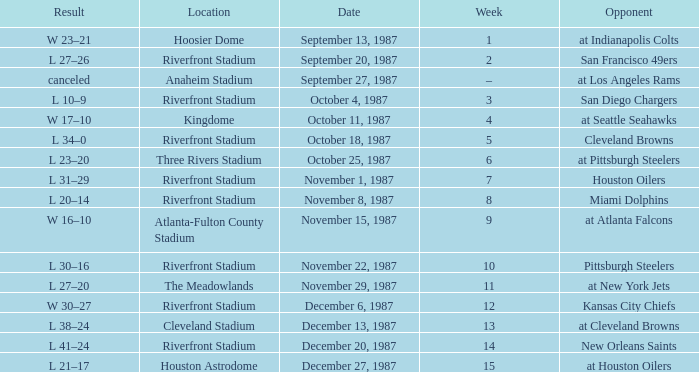Where did the game against the houston oilers take place? Riverfront Stadium. 